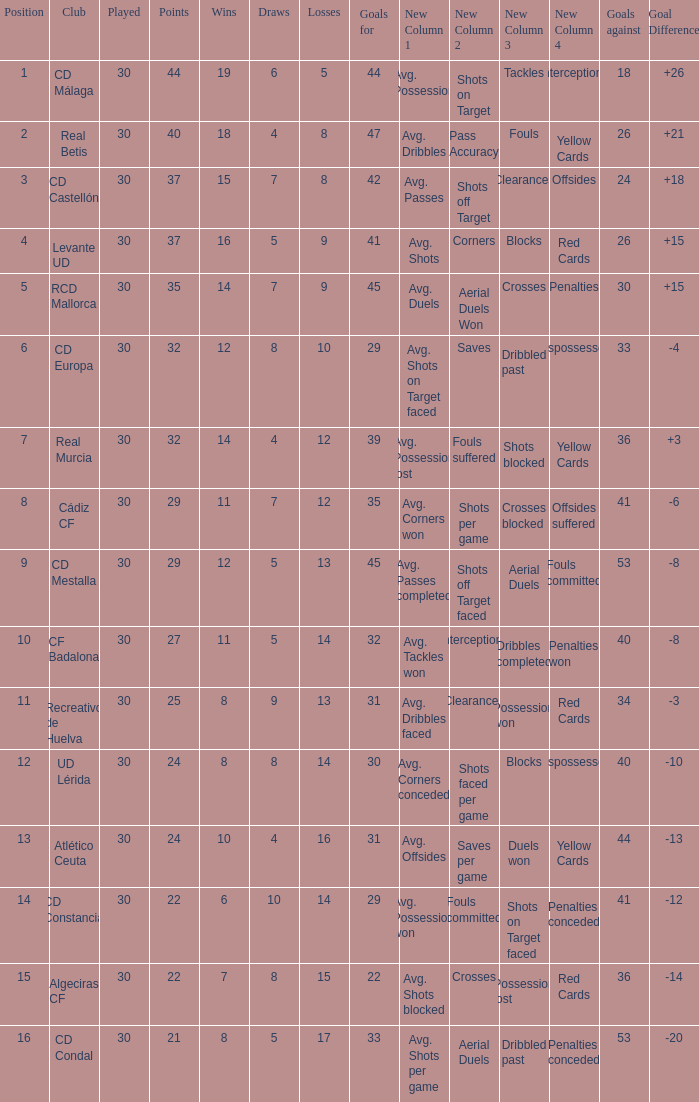What is the losses when the goal difference is larger than 26? None. 